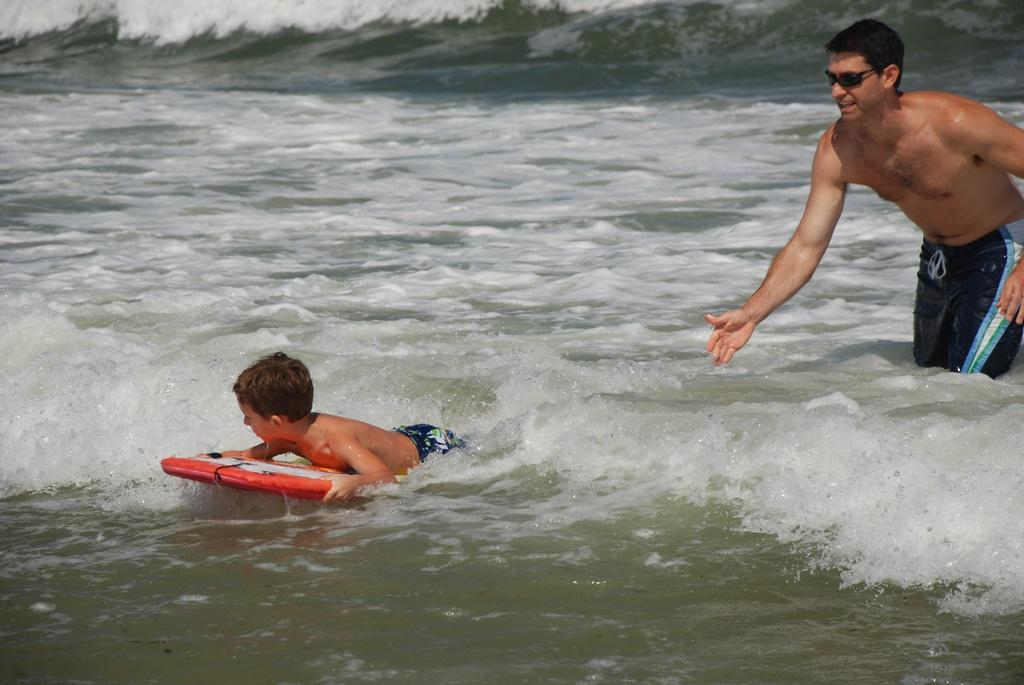What is the main subject of the image? There is a man standing in the image. What is the kid doing in the image? The kid is rowing in the image. What is the likely object the kid is rowing on? The object the kid is rowing on is likely to be a boat or similar watercraft. Where is the image taken? The image is taken in a sea. What type of chain can be seen connecting the man and the kid in the image? There is no chain present in the image connecting the man and the kid. Is there any ice visible in the image? There is no ice visible in the image; it is taken in a sea. 